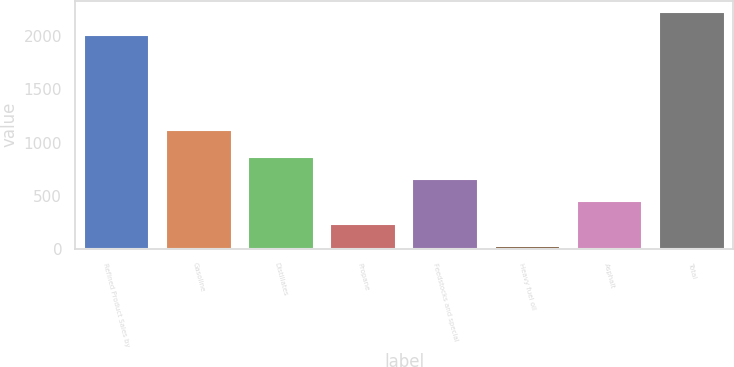<chart> <loc_0><loc_0><loc_500><loc_500><bar_chart><fcel>Refined Product Sales by<fcel>Gasoline<fcel>Distillates<fcel>Propane<fcel>Feedstocks and special<fcel>Heavy fuel oil<fcel>Asphalt<fcel>Total<nl><fcel>2014<fcel>1116<fcel>866.8<fcel>237.7<fcel>657.1<fcel>28<fcel>447.4<fcel>2223.7<nl></chart> 